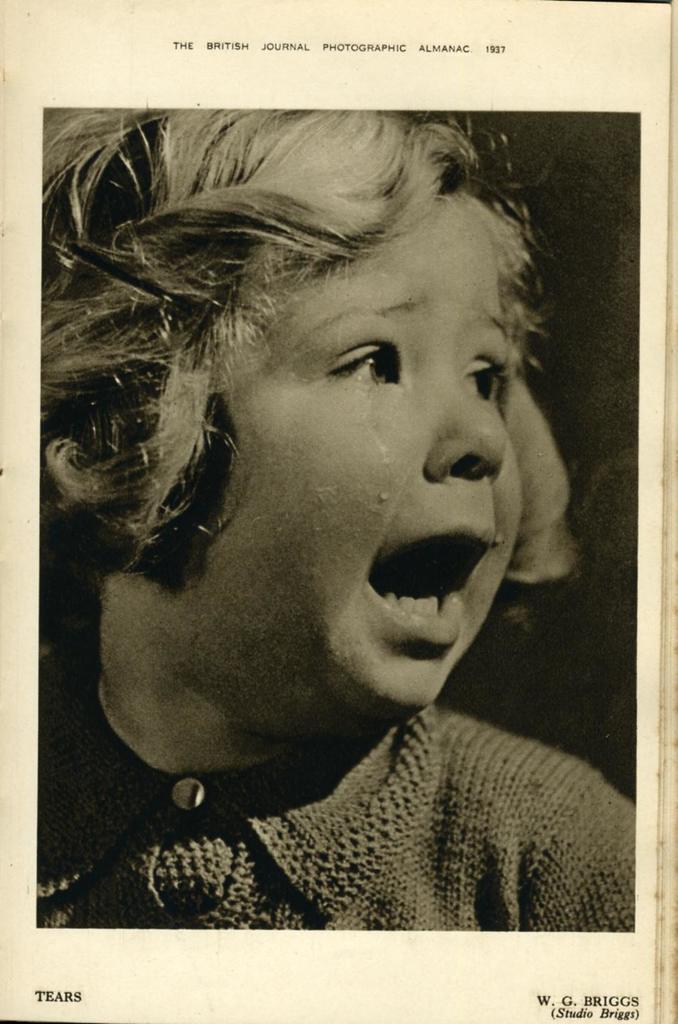Could you give a brief overview of what you see in this image? In this picture there is a girl who is wearing t-shirt and she is crying. This look like a book. On the bottom we can see author name. On the top we can see content. 